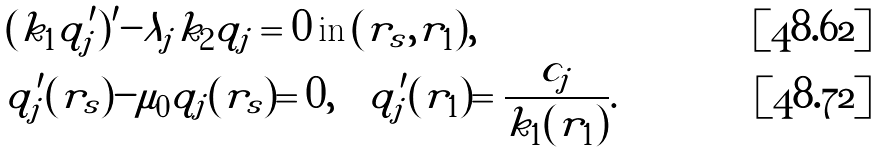Convert formula to latex. <formula><loc_0><loc_0><loc_500><loc_500>& ( k _ { 1 } q ^ { \prime } _ { j } ) ^ { \prime } - \lambda _ { j } k _ { 2 } q _ { j } = 0 \, \text {in} \, ( r _ { s } , r _ { 1 } ) , \\ & q _ { j } ^ { \prime } ( r _ { s } ) - \mu _ { 0 } q _ { j } ( r _ { s } ) = 0 , \quad q _ { j } ^ { \prime } ( r _ { 1 } ) = \frac { c _ { j } } { k _ { 1 } ( r _ { 1 } ) } .</formula> 